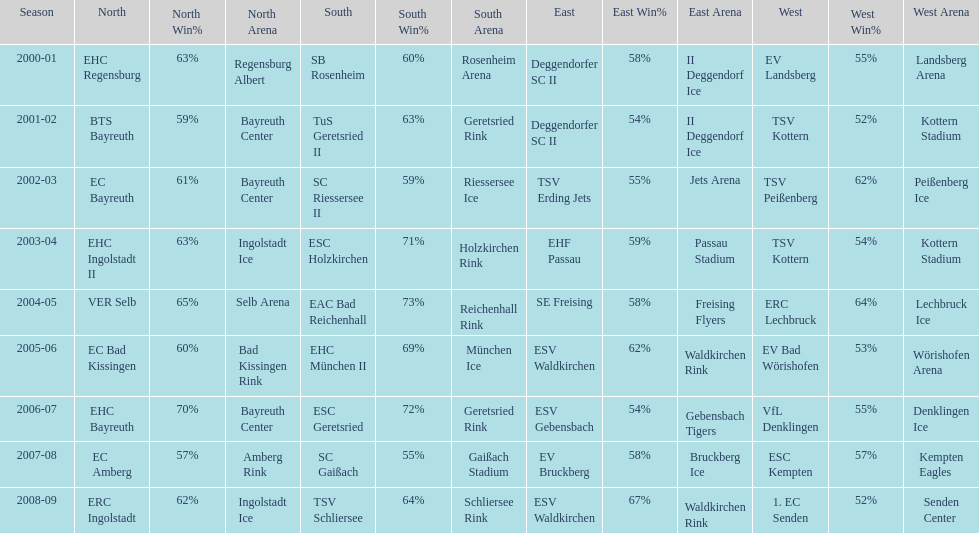What is the number of times deggendorfer sc ii is on the list? 2. 